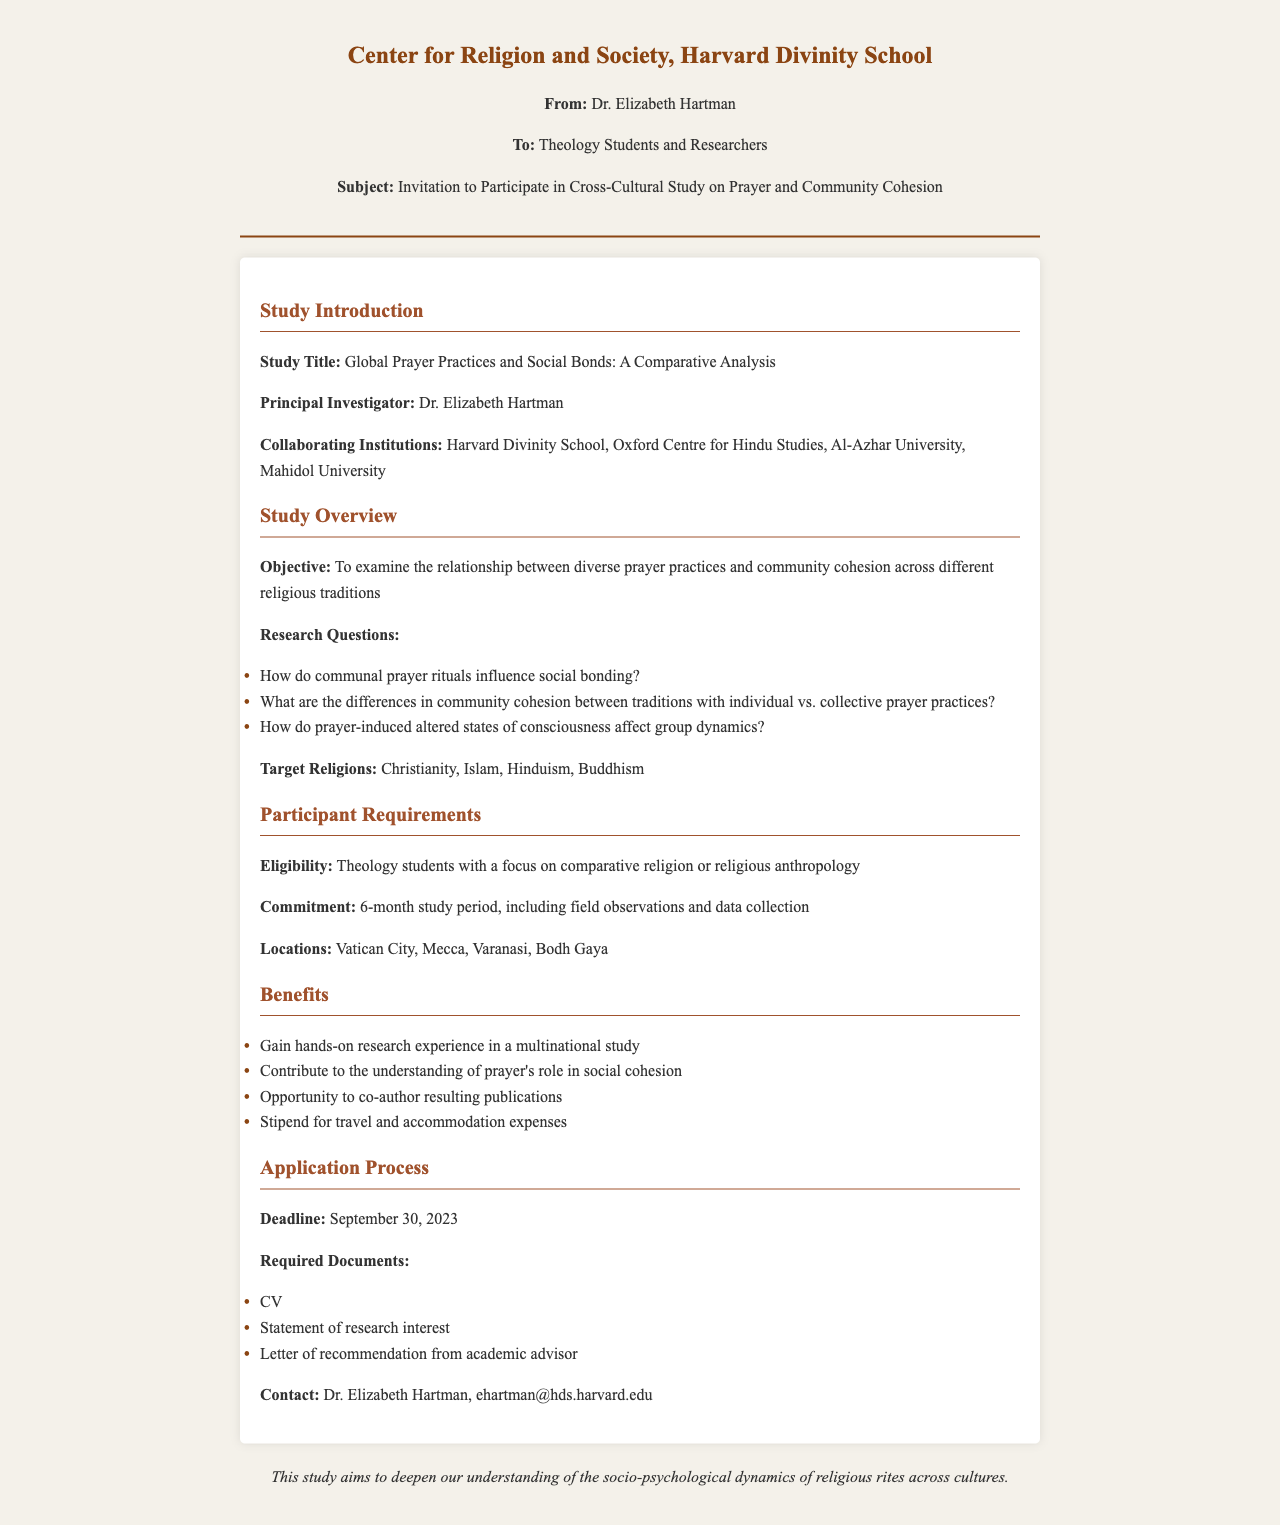what is the title of the study? The title of the study is explicitly mentioned in the document, which is "Global Prayer Practices and Social Bonds: A Comparative Analysis."
Answer: Global Prayer Practices and Social Bonds: A Comparative Analysis who is the principal investigator? The principal investigator of the study is mentioned in the document as Dr. Elizabeth Hartman.
Answer: Dr. Elizabeth Hartman what is the deadline for application submission? The deadline for application submission is specified in the document. It states that it is September 30, 2023.
Answer: September 30, 2023 how many months is the study period? The document mentions the commitment required from participants, specifying a 6-month study period.
Answer: 6-month which religious traditions are targeted in the study? The document lists the target religions for the study, which are specifically identified as Christianity, Islam, Hinduism, and Buddhism.
Answer: Christianity, Islam, Hinduism, Buddhism what type of research experience will participants gain? The document mentions that participants will gain "hands-on research experience in a multinational study."
Answer: hands-on research experience in a multinational study how many required documents must be submitted? The document outlines three specific required documents that participants must submit as part of the application process.
Answer: 3 what locations will the field observations take place? The document includes a list of specified locations where field observations will be conducted, which are Vatican City, Mecca, Varanasi, Bodh Gaya.
Answer: Vatican City, Mecca, Varanasi, Bodh Gaya what will participants receive for travel expenses? According to the document, participants will receive a "stipend for travel and accommodation expenses."
Answer: stipend for travel and accommodation expenses 